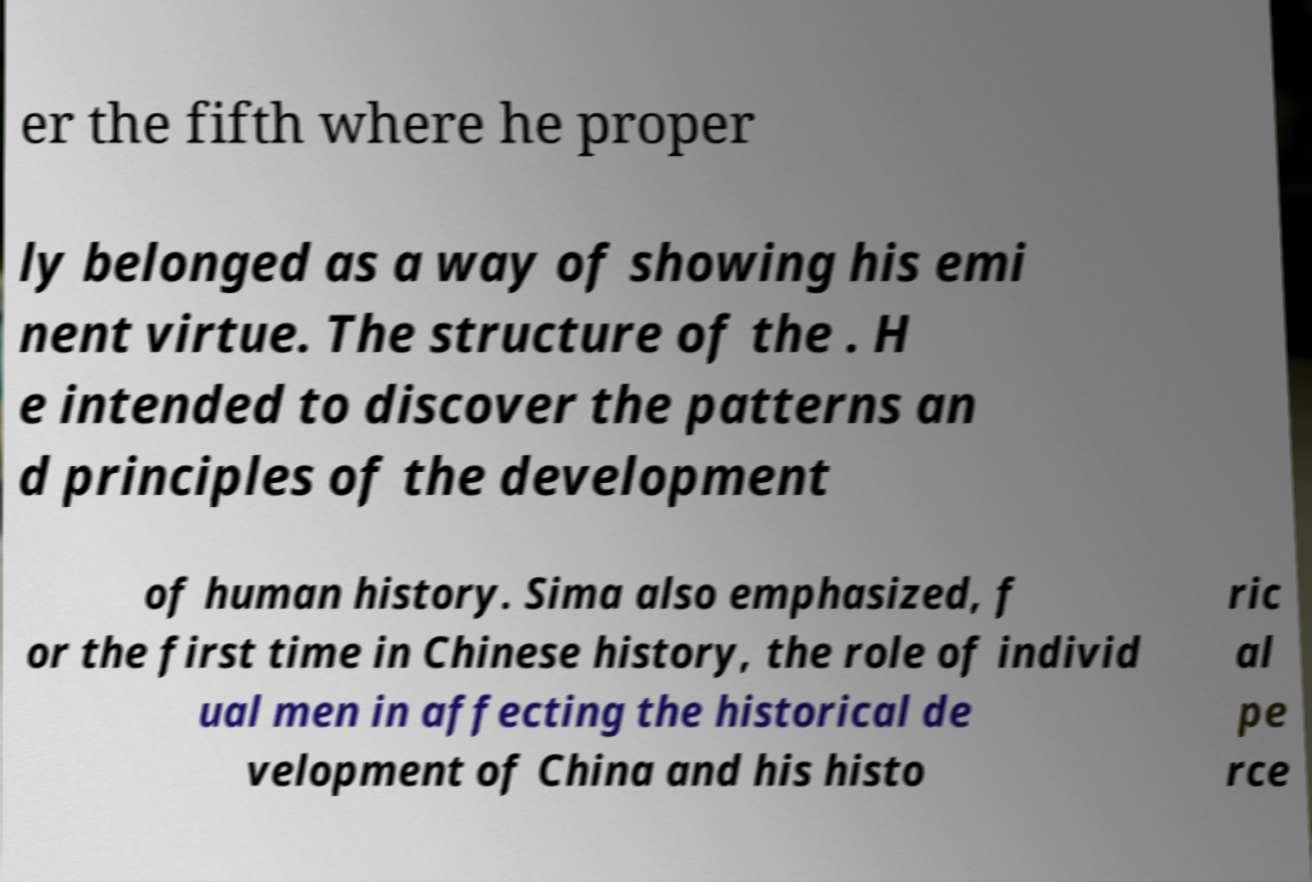Please identify and transcribe the text found in this image. er the fifth where he proper ly belonged as a way of showing his emi nent virtue. The structure of the . H e intended to discover the patterns an d principles of the development of human history. Sima also emphasized, f or the first time in Chinese history, the role of individ ual men in affecting the historical de velopment of China and his histo ric al pe rce 